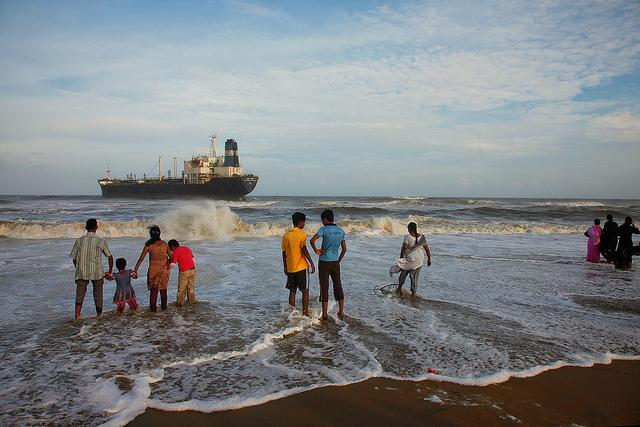How many people are visible?

Choices:
A) five
B) 22
C) ten
D) 15 ten 